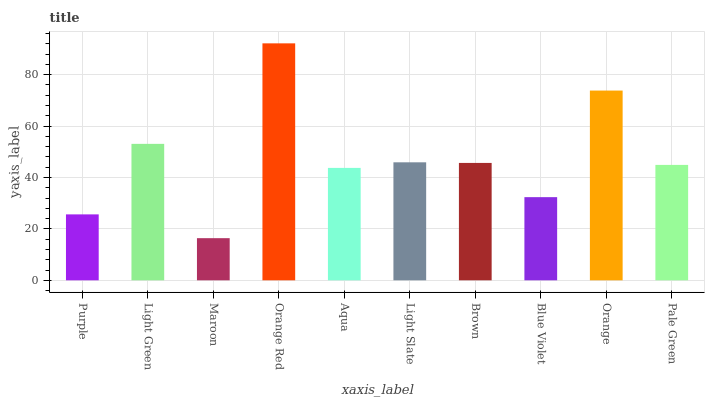Is Maroon the minimum?
Answer yes or no. Yes. Is Orange Red the maximum?
Answer yes or no. Yes. Is Light Green the minimum?
Answer yes or no. No. Is Light Green the maximum?
Answer yes or no. No. Is Light Green greater than Purple?
Answer yes or no. Yes. Is Purple less than Light Green?
Answer yes or no. Yes. Is Purple greater than Light Green?
Answer yes or no. No. Is Light Green less than Purple?
Answer yes or no. No. Is Brown the high median?
Answer yes or no. Yes. Is Pale Green the low median?
Answer yes or no. Yes. Is Pale Green the high median?
Answer yes or no. No. Is Light Green the low median?
Answer yes or no. No. 